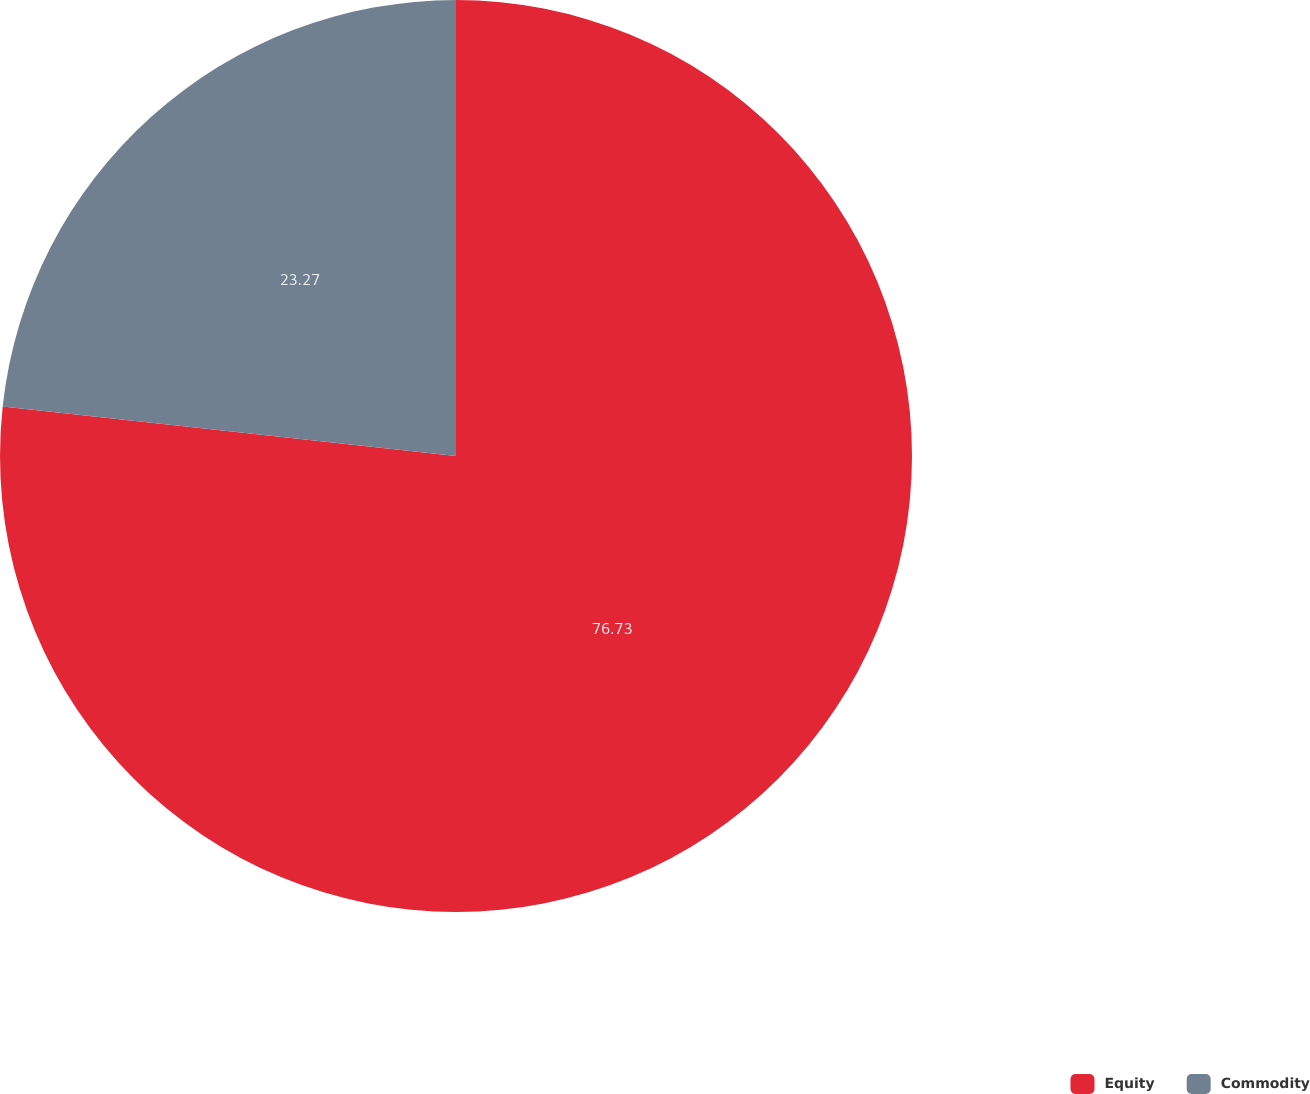Convert chart to OTSL. <chart><loc_0><loc_0><loc_500><loc_500><pie_chart><fcel>Equity<fcel>Commodity<nl><fcel>76.73%<fcel>23.27%<nl></chart> 